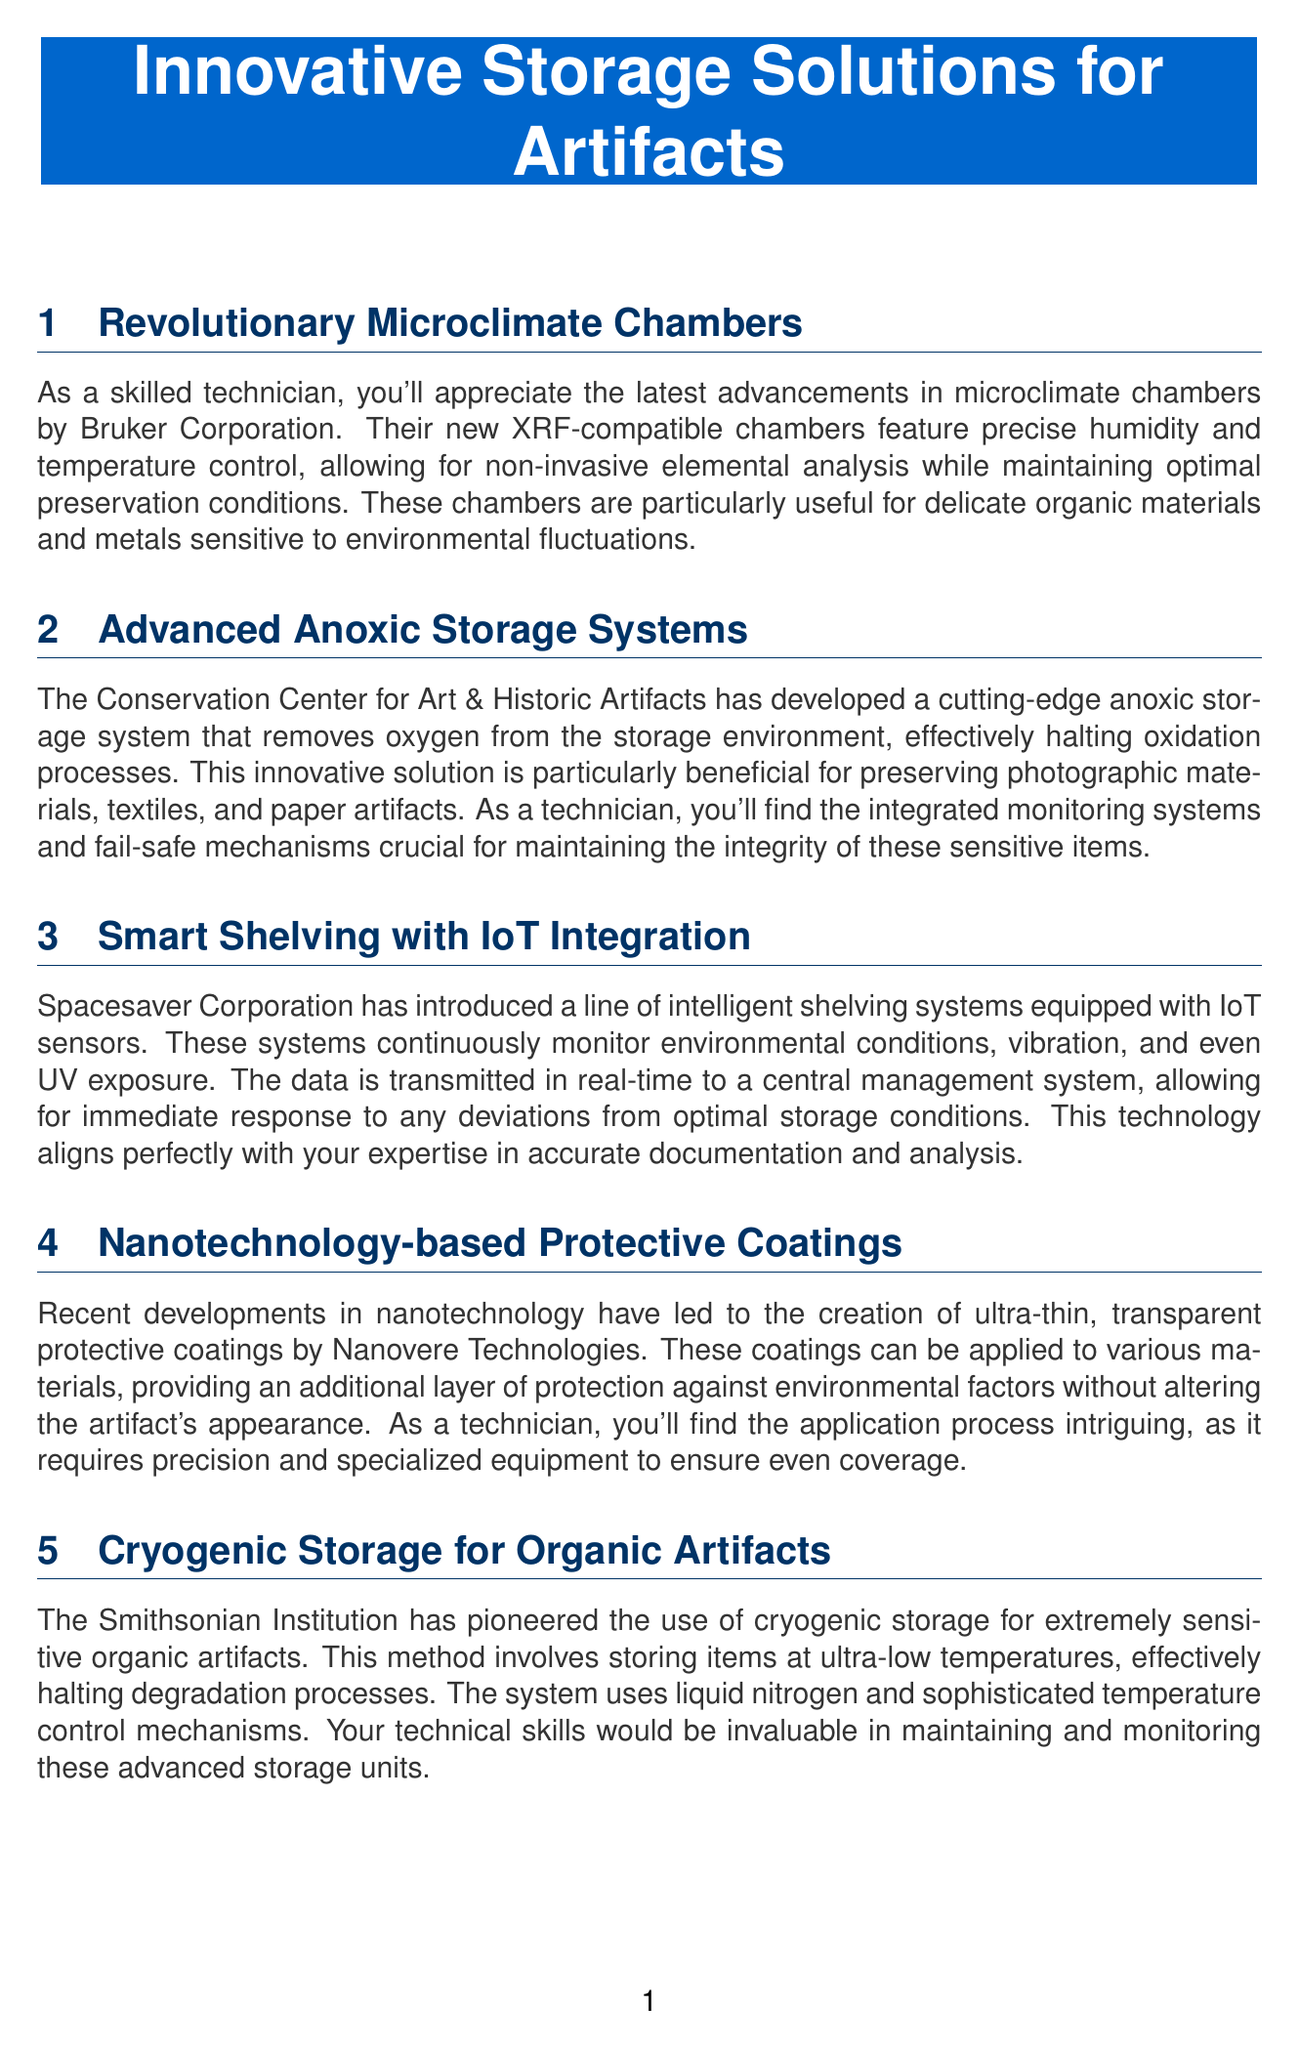what is the name of the company that developed microclimate chambers? The document states that the microclimate chambers were developed by Bruker Corporation.
Answer: Bruker Corporation which organization has created an advanced anoxic storage system? According to the document, the Conservation Center for Art & Historic Artifacts developed an advanced anoxic storage system.
Answer: Conservation Center for Art & Historic Artifacts what type of monitoring do the smart shelving systems perform? The document mentions that the smart shelving systems monitor environmental conditions, vibration, and UV exposure.
Answer: environmental conditions, vibration, and UV exposure what is the primary benefit of the cryogenic storage method? The document indicates that the primary benefit of the cryogenic storage method is to halt degradation processes.
Answer: halt degradation processes which technology is used for creating custom storage supports and enclosures? The document describes the use of high-precision 3D scanners for creating custom storage supports and enclosures.
Answer: high-precision 3D scanners why is the application process for protective coatings considered intriguing? The document notes that the application process is intriguing because it requires precision and specialized equipment for even coverage.
Answer: precision and specialized equipment how does the anoxic storage system affect oxidation processes? The anoxic storage system removes oxygen from the storage environment, effectively halting oxidation processes.
Answer: halting oxidation processes what is used for cryogenic storage at the Smithsonian Institution? The document states that liquid nitrogen is used for cryogenic storage at the Smithsonian Institution.
Answer: liquid nitrogen 